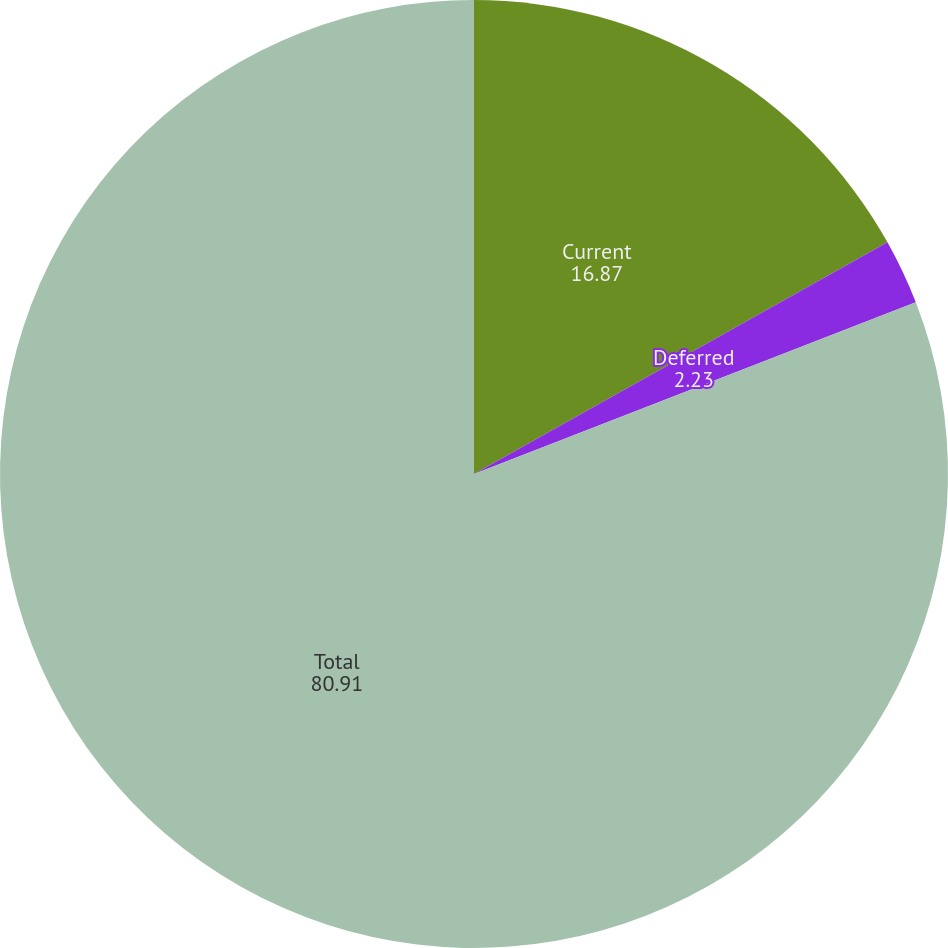Convert chart. <chart><loc_0><loc_0><loc_500><loc_500><pie_chart><fcel>Current<fcel>Deferred<fcel>Total<nl><fcel>16.87%<fcel>2.23%<fcel>80.91%<nl></chart> 